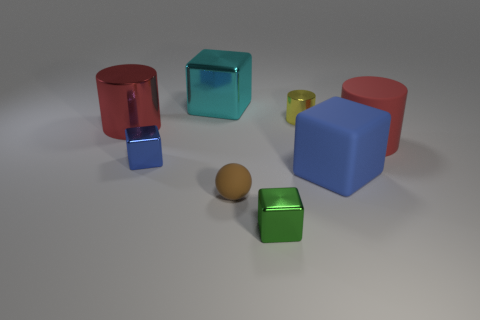There is a block in front of the small brown matte thing; is it the same color as the small thing that is behind the blue shiny block?
Your response must be concise. No. What is the size of the blue metallic thing?
Provide a short and direct response. Small. What number of big objects are gray matte balls or green blocks?
Offer a terse response. 0. What is the color of the rubber block that is the same size as the cyan shiny object?
Provide a succinct answer. Blue. How many other things are the same shape as the yellow shiny thing?
Your response must be concise. 2. Is there a blue thing that has the same material as the small yellow cylinder?
Keep it short and to the point. Yes. Is the material of the blue block that is on the right side of the tiny brown rubber sphere the same as the big object behind the big red metal thing?
Ensure brevity in your answer.  No. How many red cylinders are there?
Your response must be concise. 2. The tiny object in front of the small ball has what shape?
Your answer should be very brief. Cube. How many other things are there of the same size as the green block?
Offer a very short reply. 3. 